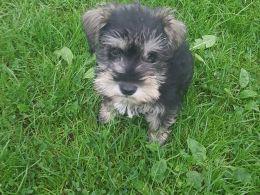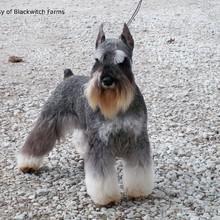The first image is the image on the left, the second image is the image on the right. Given the left and right images, does the statement "The right image has a dog with it's from feet propped on stone while looking at the camera" hold true? Answer yes or no. No. 